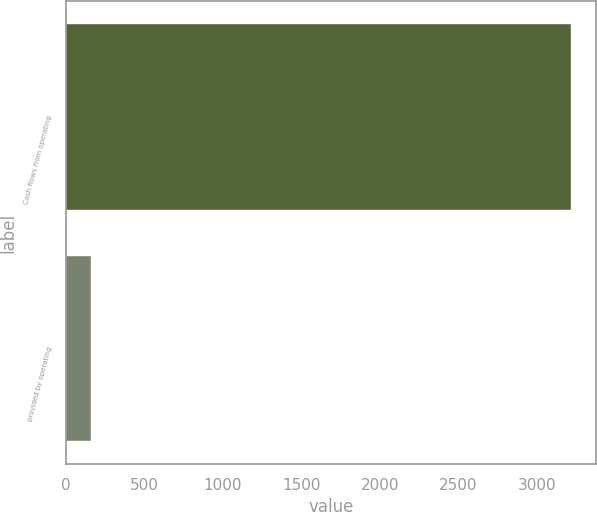Convert chart. <chart><loc_0><loc_0><loc_500><loc_500><bar_chart><fcel>Cash flows from operating<fcel>provided by operating<nl><fcel>3216<fcel>162<nl></chart> 